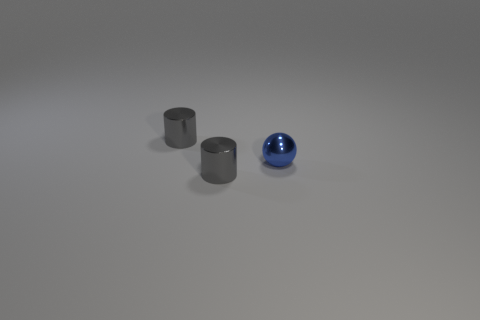Add 3 blue spheres. How many objects exist? 6 Subtract all cylinders. How many objects are left? 1 Add 1 small brown shiny spheres. How many small brown shiny spheres exist? 1 Subtract 0 cyan balls. How many objects are left? 3 Subtract all gray metal cylinders. Subtract all blue spheres. How many objects are left? 0 Add 1 tiny gray metallic things. How many tiny gray metallic things are left? 3 